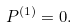Convert formula to latex. <formula><loc_0><loc_0><loc_500><loc_500>P ^ { ( 1 ) } = 0 .</formula> 